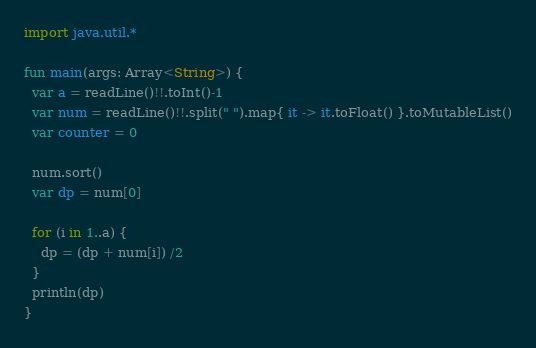Convert code to text. <code><loc_0><loc_0><loc_500><loc_500><_Kotlin_>import java.util.*
 
fun main(args: Array<String>) {
  var a = readLine()!!.toInt()-1
  var num = readLine()!!.split(" ").map{ it -> it.toFloat() }.toMutableList()
  var counter = 0
  
  num.sort()
  var dp = num[0]

  for (i in 1..a) {
    dp = (dp + num[i]) /2
  }
  println(dp)
}</code> 